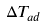<formula> <loc_0><loc_0><loc_500><loc_500>\Delta T _ { a d }</formula> 